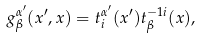Convert formula to latex. <formula><loc_0><loc_0><loc_500><loc_500>g _ { \beta } ^ { \alpha ^ { \prime } } ( x ^ { \prime } , x ) = t _ { i } ^ { \alpha ^ { \prime } } ( x ^ { \prime } ) t _ { \beta } ^ { - 1 i } ( x ) ,</formula> 